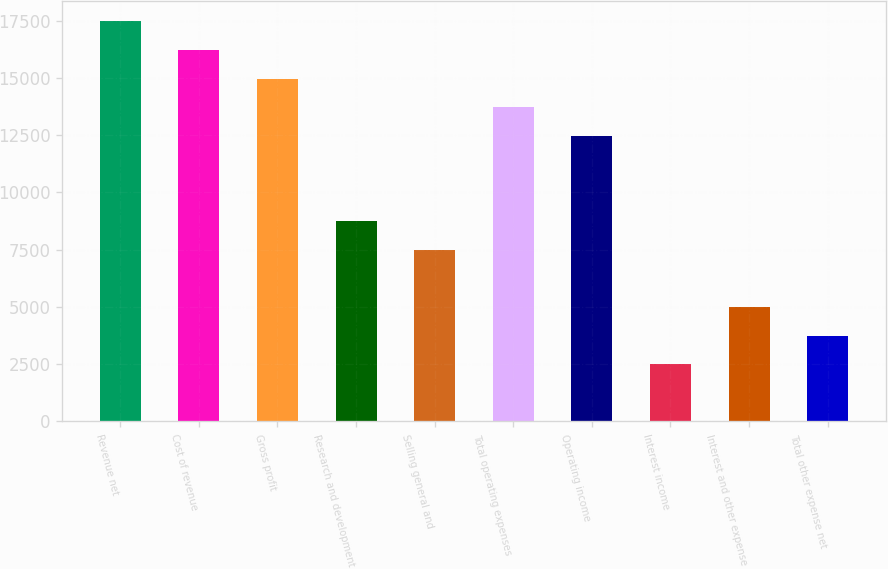<chart> <loc_0><loc_0><loc_500><loc_500><bar_chart><fcel>Revenue net<fcel>Cost of revenue<fcel>Gross profit<fcel>Research and development<fcel>Selling general and<fcel>Total operating expenses<fcel>Operating income<fcel>Interest income<fcel>Interest and other expense<fcel>Total other expense net<nl><fcel>17466.5<fcel>16219.4<fcel>14972.3<fcel>8736.56<fcel>7489.42<fcel>13725.1<fcel>12478<fcel>2500.86<fcel>4995.14<fcel>3748<nl></chart> 